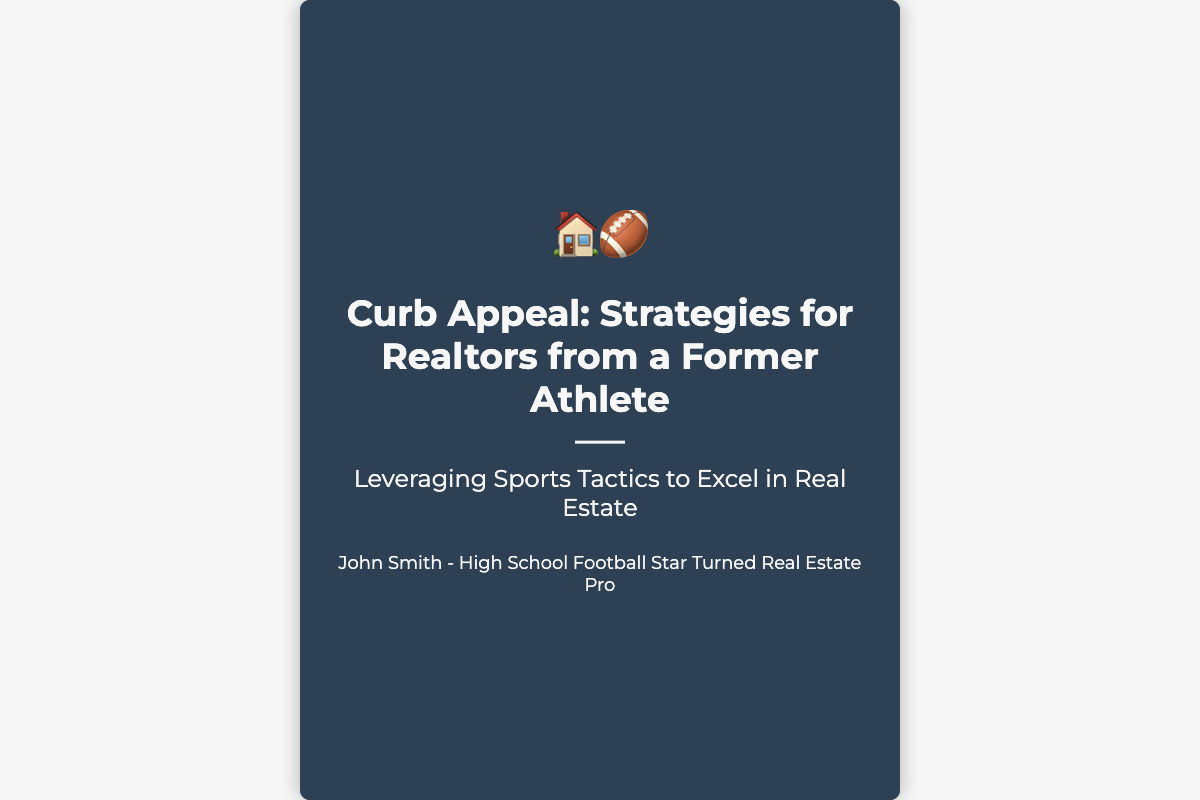what is the title of the book? The title of the book is prominently displayed on the cover.
Answer: Curb Appeal: Strategies for Realtors from a Former Athlete who is the author of the book? The author's name is listed at the bottom of the cover.
Answer: John Smith what unique perspective does the author bring to real estate? The subtitle indicates the author's background and how it relates to real estate.
Answer: Leveraging Sports Tactics to Excel in Real Estate what is the background of the author? The author's background is briefly mentioned under their name.
Answer: High School Football Star Turned Real Estate Pro how many sections does the book cover visually represent? The visual design includes two distinct sections.
Answer: Two what is the main visual theme of the book cover? The cover juxtaposes two images that relate to the content.
Answer: Sports and real estate what colors dominate the book cover? The main colors used for the cover are evident upon a close look.
Answer: Dark colors with white text what icons are featured on the book cover? Icon features at the top of the content area represent the themes.
Answer: House and football icons 